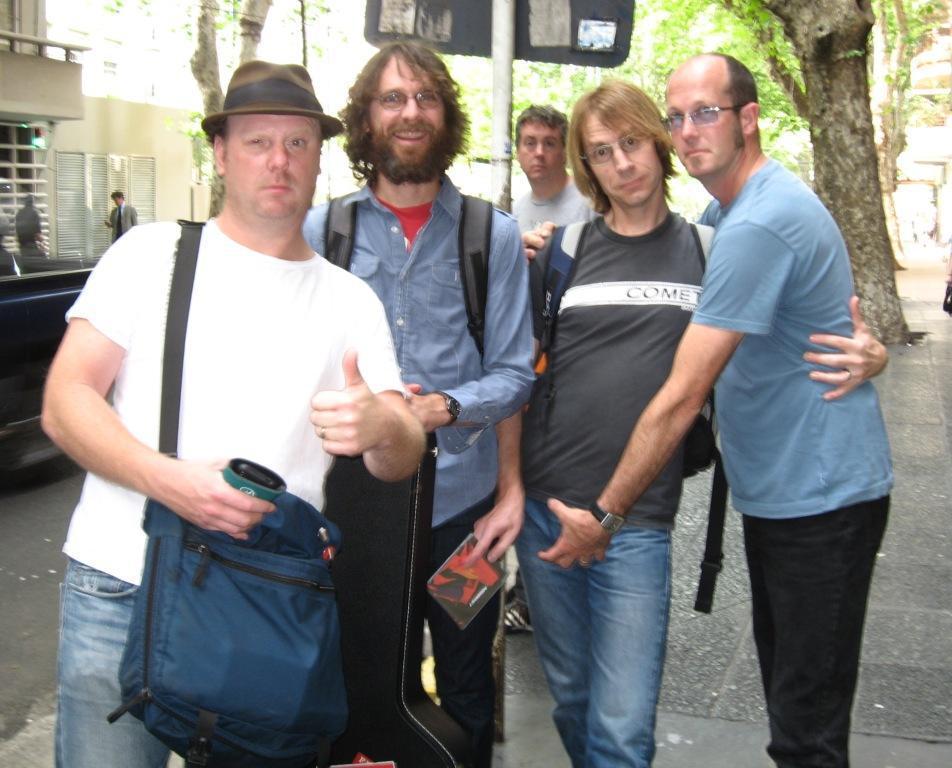Describe this image in one or two sentences. In this image we can see men standing on the road. In the background there are sign boards and trees. 